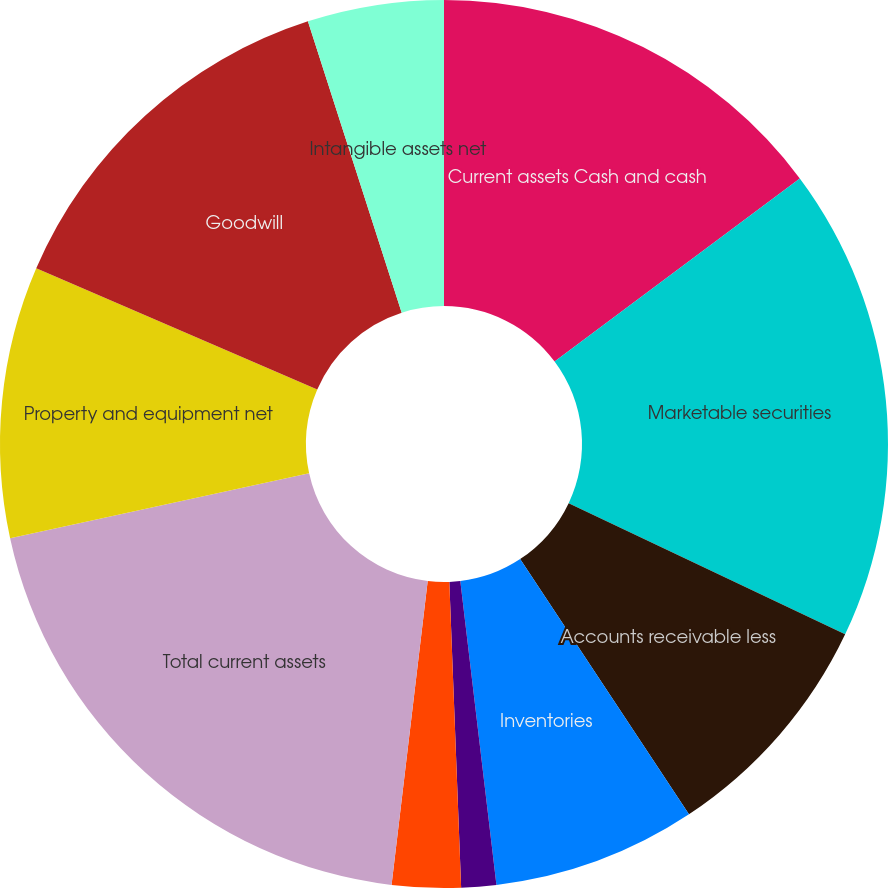Convert chart to OTSL. <chart><loc_0><loc_0><loc_500><loc_500><pie_chart><fcel>Current assets Cash and cash<fcel>Marketable securities<fcel>Accounts receivable less<fcel>Inventories<fcel>Prepaid expenses and other<fcel>Deferred income taxes<fcel>Total current assets<fcel>Property and equipment net<fcel>Goodwill<fcel>Intangible assets net<nl><fcel>14.8%<fcel>17.26%<fcel>8.65%<fcel>7.42%<fcel>1.27%<fcel>2.5%<fcel>19.72%<fcel>9.88%<fcel>13.57%<fcel>4.96%<nl></chart> 